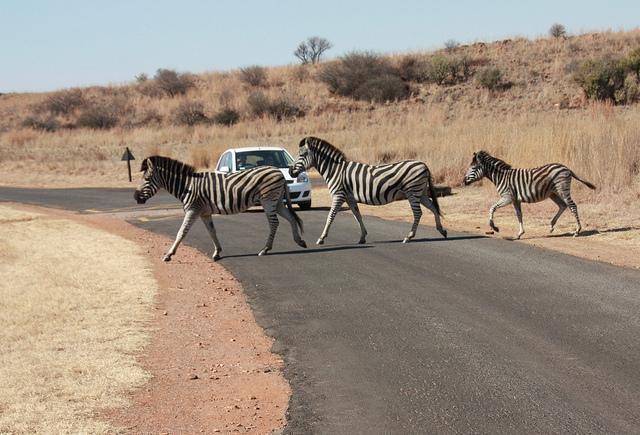How many animals are crossing the road?
Give a very brief answer. 3. How many zebras are in the photo?
Give a very brief answer. 3. 